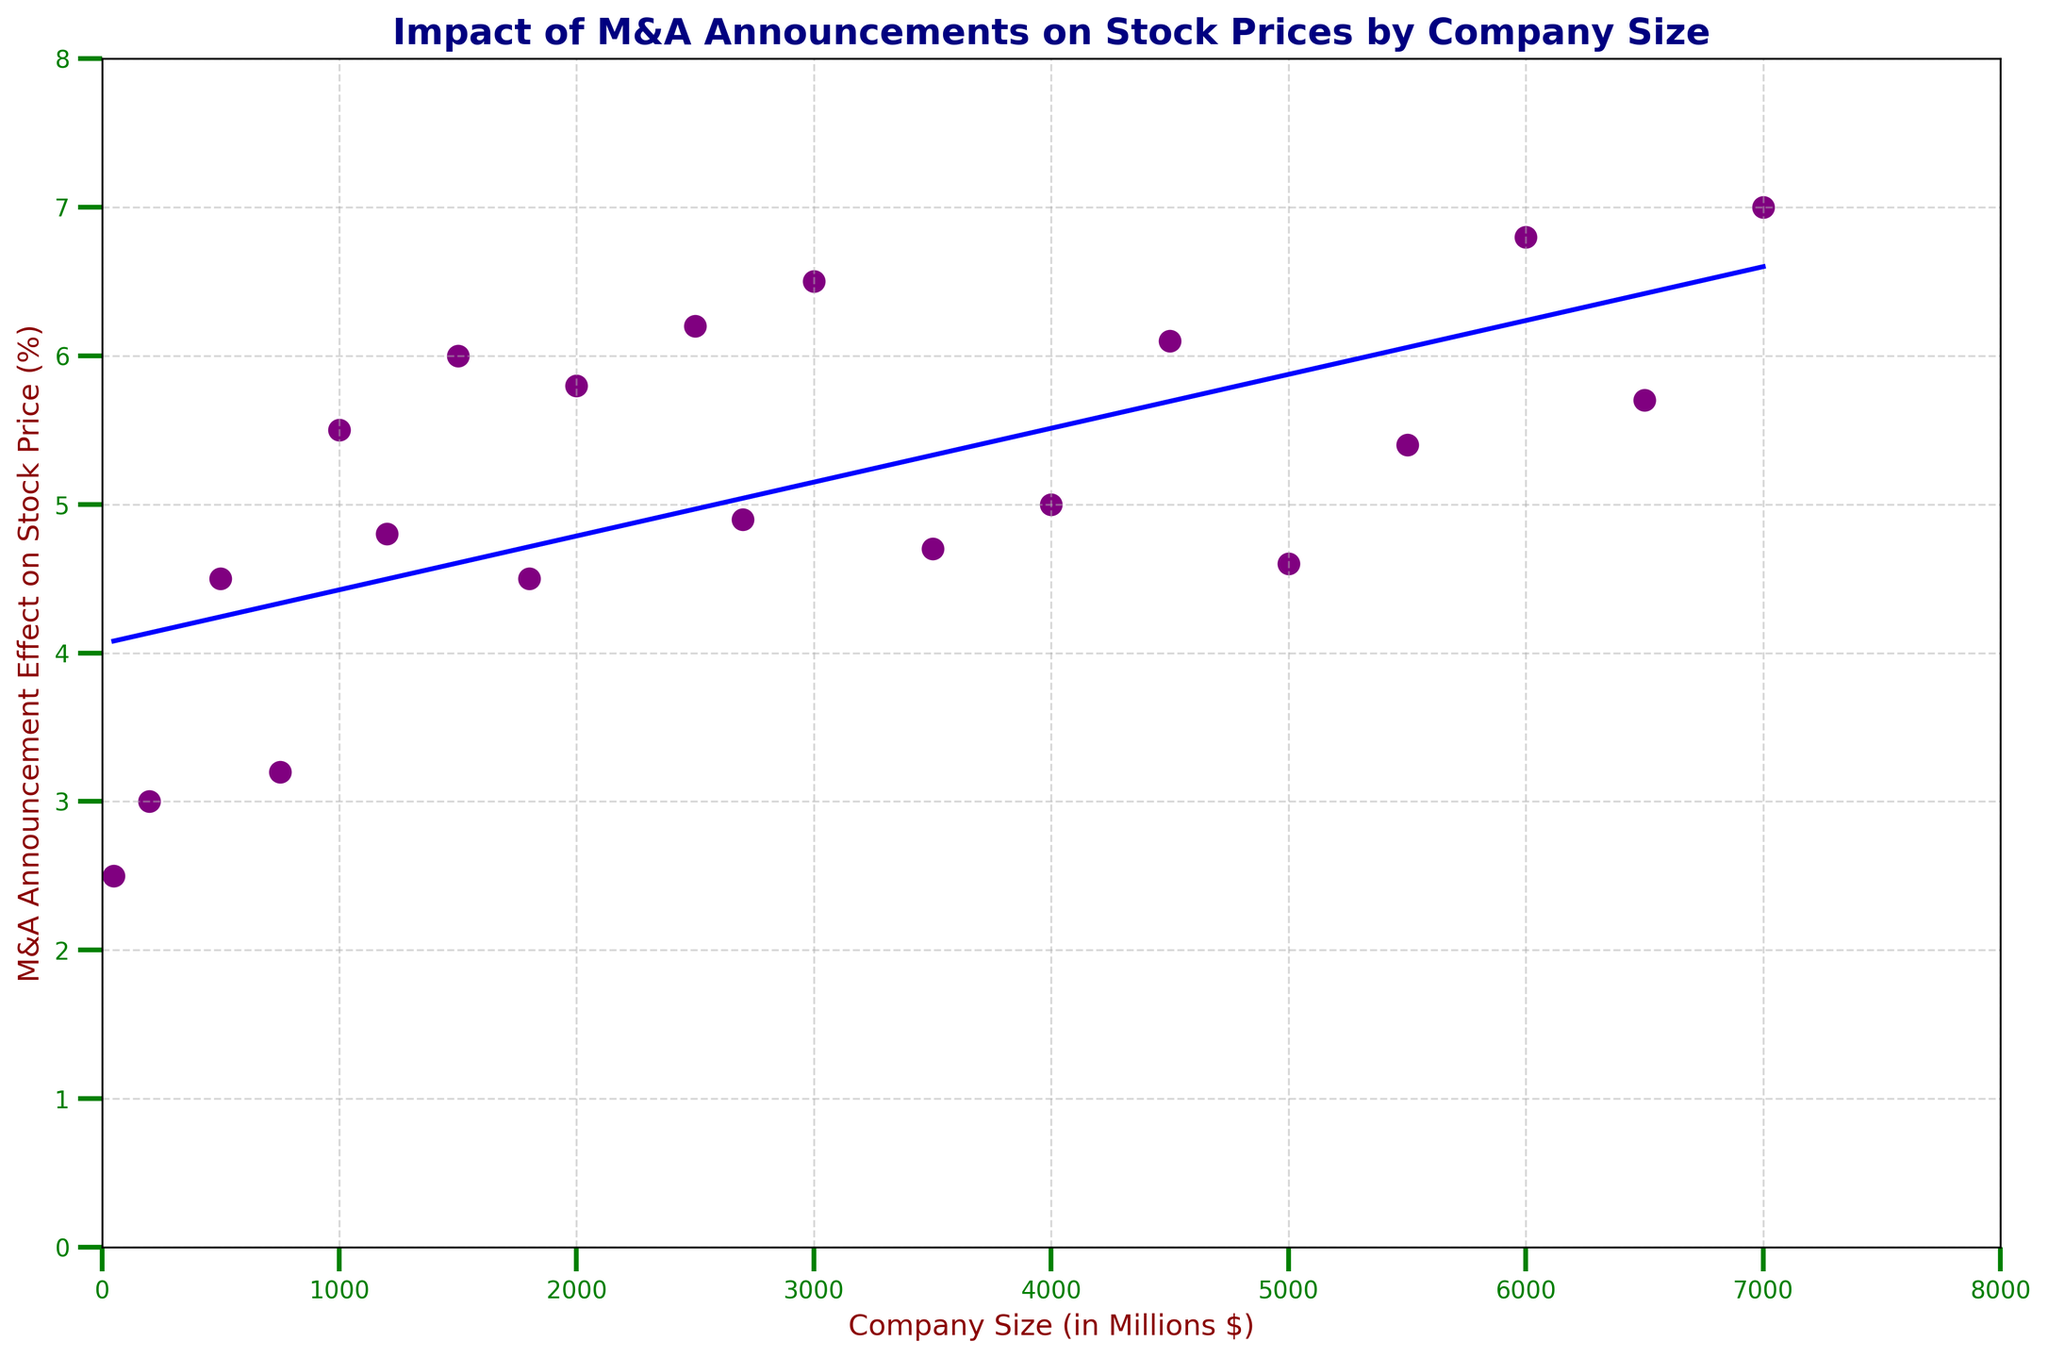Which company size has the highest M&A announcement effect on stock price? The figure shows that the company size of 7000 million dollars has the highest M&A announcement effect on stock price, reaching 7.0%.
Answer: 7000 What is the average M&A announcement effect on stock price for companies larger than 5000 million dollars? Identify data points larger than 5000 million dollars: 5500 (5.4), 6000 (6.8), 6500 (5.7), 7000 (7.0). Calculate the average (5.4+6.8+5.7+7.0)/4 = 6.225.
Answer: 6.225 Compare the M&A announcement effect on stock price between company sizes of 500 and 5000 million dollars. Which is higher? The figure shows that the company size of 500 million dollars has an M&A announcement effect of 4.5%, whereas the company size of 5000 million dollars has an effect of 4.6%. Therefore, 5000 million dollars is higher.
Answer: 5000 million dollars Does the trend line show an overall increase or decrease in M&A announcement effects on stock price as company size increases? The trend line in the figure is upward sloping, indicating an overall increase in M&A announcement effects on stock price as company size increases.
Answer: Increase Which color represents the scatter points indicating the data for company size and M&A announcement effect on stock price? The scatter points on the figure are indicated by the color purple.
Answer: Purple What is the M&A announcement effect on stock price for a company size of 1200 million dollars, and how does it compare to the effect for a company size of 1000 million dollars? The figure shows that the M&A announcement effect for a company size of 1200 million dollars is 4.8%, and for a company size of 1000 million dollars, it is 5.5%. The effect is higher for the 1000 million dollar company size.
Answer: 1000 million dollars What is the median M&A announcement effect on stock price for all the companies? First, list the data points in order: 2.5, 3.0, 3.2, 4.5, 4.5, 4.6, 4.7, 4.8, 4.9, 5.0, 5.4, 5.5, 5.7, 5.8, 6.0, 6.1, 6.2, 6.5, 6.8, 7.0. There are 20 points, so the median is the average of the 10th and 11th values (5.0+5.4)/2 = 5.2%.
Answer: 5.2% What is the effect difference between the largest and smallest company sizes illustrated in the figure? The smallest company size has an M&A effect of 2.5% (50 million dollars), and the largest size has an effect of 7.0% (7000 million dollars). The difference is 7.0% - 2.5% = 4.5%.
Answer: 4.5% Is there any company size range where the M&A announcement effect peaks and then declines before rising again? The figure shows that the M&A announcement effect peaks around 6000 million dollars (6.8%) and then declines at 6500 million dollars (5.7%) before rising again at 7000 million dollars (7.0%).
Answer: Yes How many data points have an M&A announcement effect on stock price of greater than 5%? Count the data points with an effect greater than 5%: 6.0, 5.8, 6.2, 6.5, 6.1, 5.4, 6.8, 5.7, 7.0. There are 9 such data points.
Answer: 9 